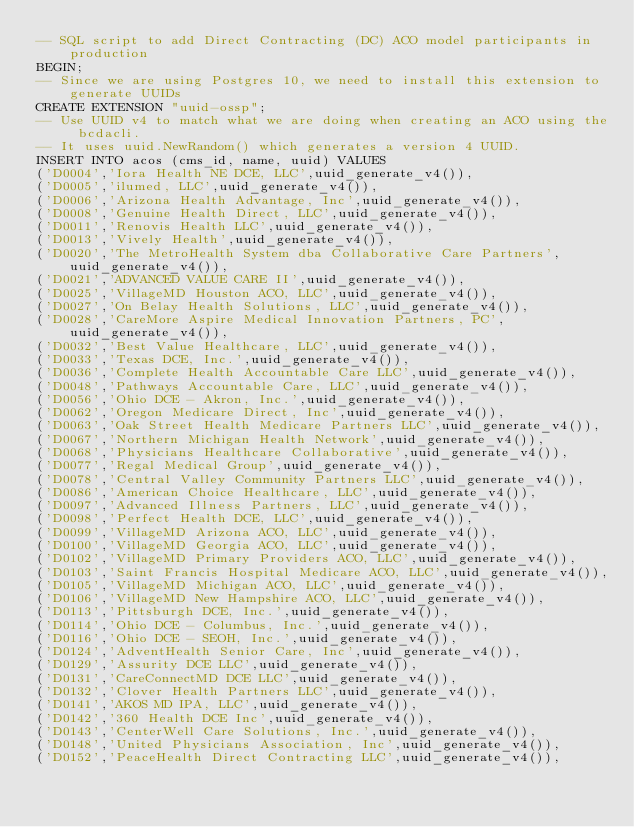<code> <loc_0><loc_0><loc_500><loc_500><_SQL_>-- SQL script to add Direct Contracting (DC) ACO model participants in production
BEGIN;
-- Since we are using Postgres 10, we need to install this extension to generate UUIDs
CREATE EXTENSION "uuid-ossp";
-- Use UUID v4 to match what we are doing when creating an ACO using the bcdacli.
-- It uses uuid.NewRandom() which generates a version 4 UUID.
INSERT INTO acos (cms_id, name, uuid) VALUES
('D0004','Iora Health NE DCE, LLC',uuid_generate_v4()),
('D0005','ilumed, LLC',uuid_generate_v4()),
('D0006','Arizona Health Advantage, Inc',uuid_generate_v4()),
('D0008','Genuine Health Direct, LLC',uuid_generate_v4()),
('D0011','Renovis Health LLC',uuid_generate_v4()),
('D0013','Vively Health',uuid_generate_v4()),
('D0020','The MetroHealth System dba Collaborative Care Partners',uuid_generate_v4()),
('D0021','ADVANCED VALUE CARE II',uuid_generate_v4()),
('D0025','VillageMD Houston ACO, LLC',uuid_generate_v4()),
('D0027','On Belay Health Solutions, LLC',uuid_generate_v4()),
('D0028','CareMore Aspire Medical Innovation Partners, PC',uuid_generate_v4()),
('D0032','Best Value Healthcare, LLC',uuid_generate_v4()),
('D0033','Texas DCE, Inc.',uuid_generate_v4()),
('D0036','Complete Health Accountable Care LLC',uuid_generate_v4()),
('D0048','Pathways Accountable Care, LLC',uuid_generate_v4()),
('D0056','Ohio DCE - Akron, Inc.',uuid_generate_v4()),
('D0062','Oregon Medicare Direct, Inc',uuid_generate_v4()),
('D0063','Oak Street Health Medicare Partners LLC',uuid_generate_v4()),
('D0067','Northern Michigan Health Network',uuid_generate_v4()),
('D0068','Physicians Healthcare Collaborative',uuid_generate_v4()),
('D0077','Regal Medical Group',uuid_generate_v4()),
('D0078','Central Valley Community Partners LLC',uuid_generate_v4()),
('D0086','American Choice Healthcare, LLC',uuid_generate_v4()),
('D0097','Advanced Illness Partners, LLC',uuid_generate_v4()),
('D0098','Perfect Health DCE, LLC',uuid_generate_v4()),
('D0099','VillageMD Arizona ACO, LLC',uuid_generate_v4()),
('D0100','VillageMD Georgia ACO, LLC',uuid_generate_v4()),
('D0102','VillageMD Primary Providers ACO, LLC',uuid_generate_v4()),
('D0103','Saint Francis Hospital Medicare ACO, LLC',uuid_generate_v4()),
('D0105','VillageMD Michigan ACO, LLC',uuid_generate_v4()),
('D0106','VillageMD New Hampshire ACO, LLC',uuid_generate_v4()),
('D0113','Pittsburgh DCE, Inc.',uuid_generate_v4()),
('D0114','Ohio DCE - Columbus, Inc.',uuid_generate_v4()),
('D0116','Ohio DCE - SEOH, Inc.',uuid_generate_v4()),
('D0124','AdventHealth Senior Care, Inc',uuid_generate_v4()),
('D0129','Assurity DCE LLC',uuid_generate_v4()),
('D0131','CareConnectMD DCE LLC',uuid_generate_v4()),
('D0132','Clover Health Partners LLC',uuid_generate_v4()),
('D0141','AKOS MD IPA, LLC',uuid_generate_v4()),
('D0142','360 Health DCE Inc',uuid_generate_v4()),
('D0143','CenterWell Care Solutions, Inc.',uuid_generate_v4()),
('D0148','United Physicians Association, Inc',uuid_generate_v4()),
('D0152','PeaceHealth Direct Contracting LLC',uuid_generate_v4()),</code> 